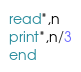Convert code to text. <code><loc_0><loc_0><loc_500><loc_500><_FORTRAN_>read*,n
print*,n/3
end</code> 